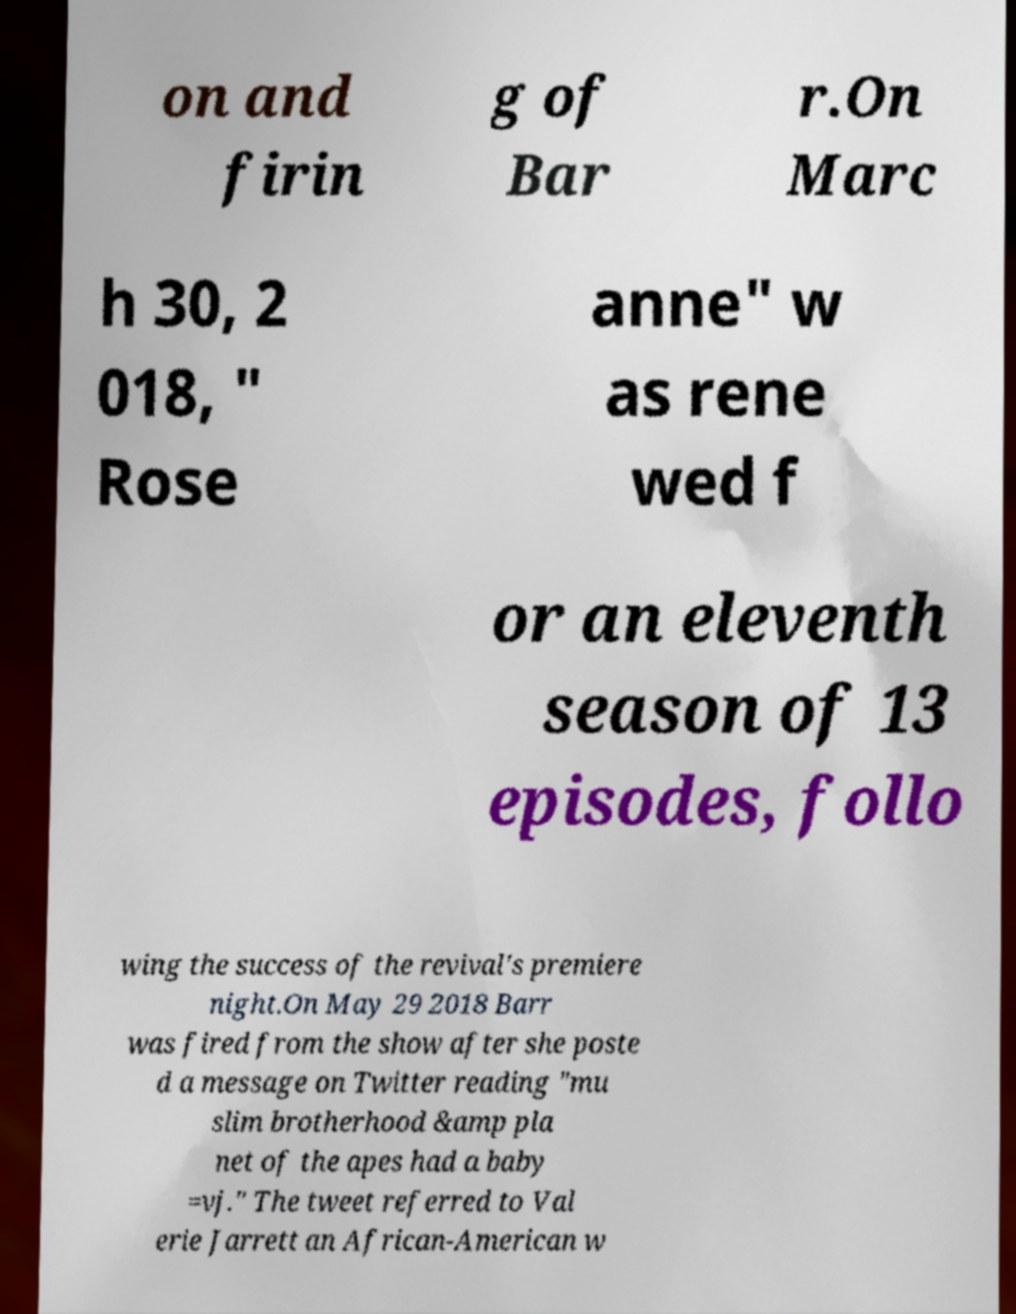Could you extract and type out the text from this image? on and firin g of Bar r.On Marc h 30, 2 018, " Rose anne" w as rene wed f or an eleventh season of 13 episodes, follo wing the success of the revival's premiere night.On May 29 2018 Barr was fired from the show after she poste d a message on Twitter reading "mu slim brotherhood &amp pla net of the apes had a baby =vj." The tweet referred to Val erie Jarrett an African-American w 